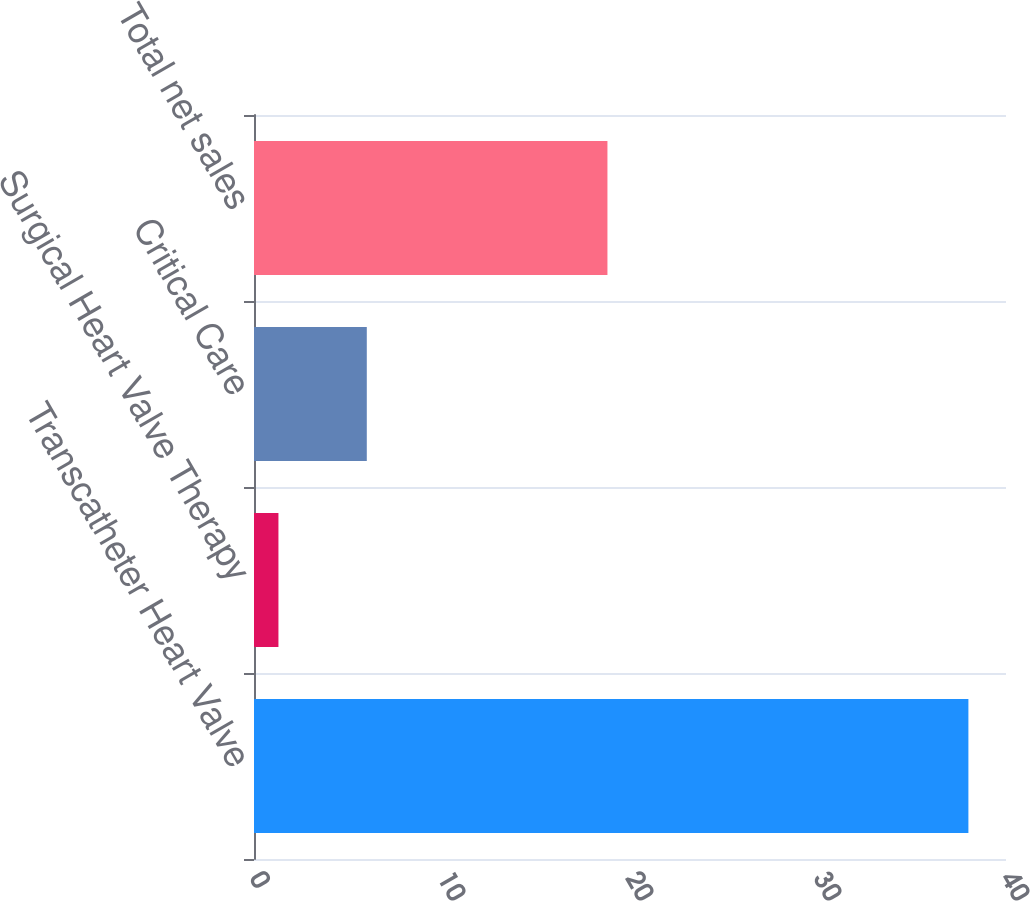Convert chart. <chart><loc_0><loc_0><loc_500><loc_500><bar_chart><fcel>Transcatheter Heart Valve<fcel>Surgical Heart Valve Therapy<fcel>Critical Care<fcel>Total net sales<nl><fcel>38<fcel>1.3<fcel>6<fcel>18.8<nl></chart> 